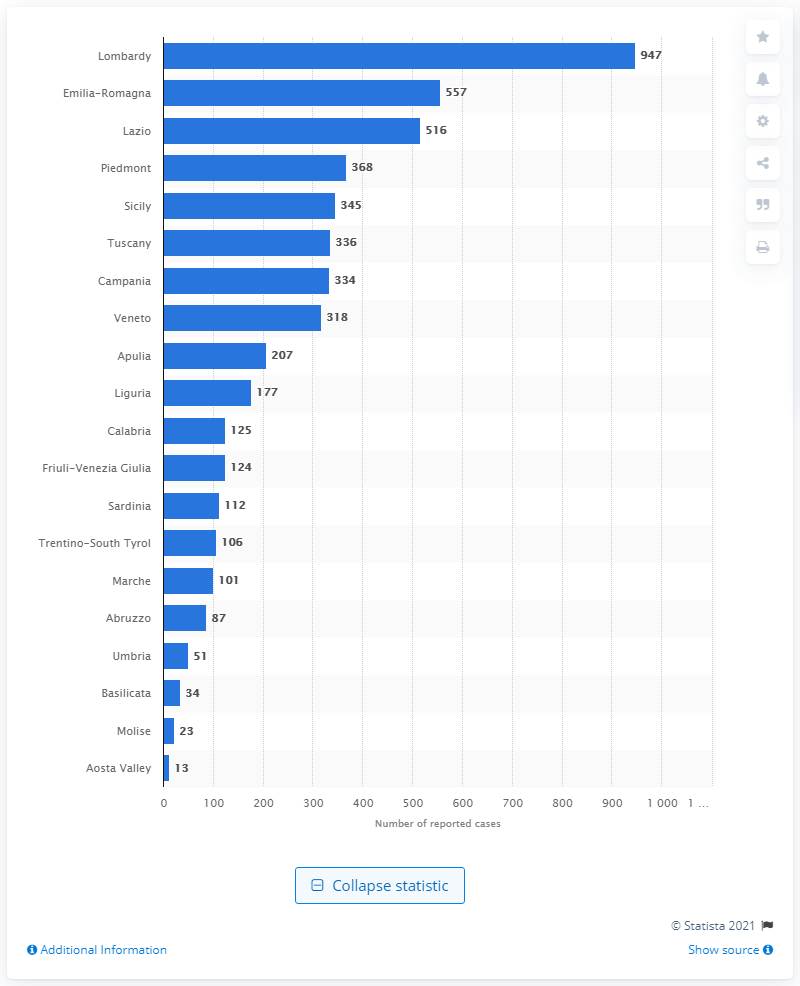Point out several critical features in this image. In Lombardy, the highest number of sexual violence cases were reported to the authorities. 